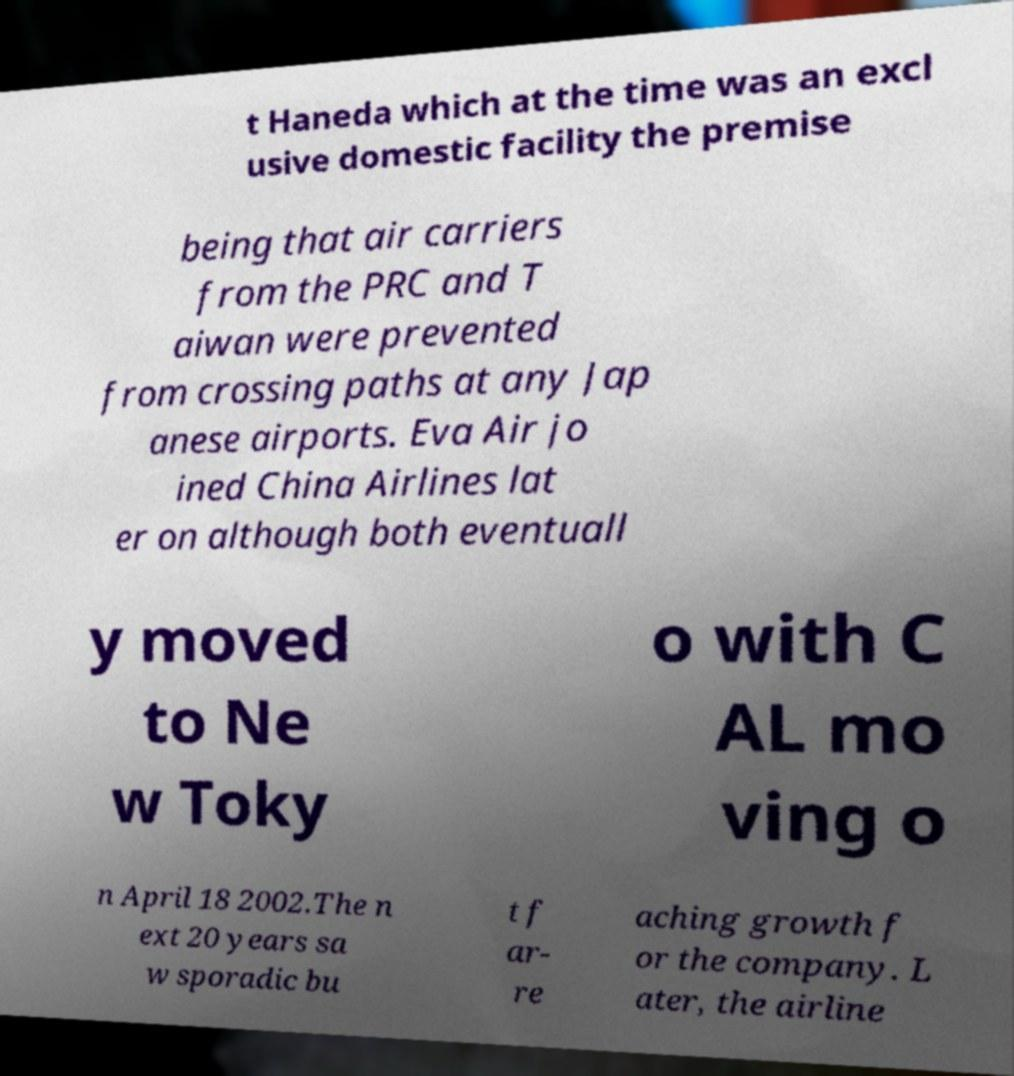For documentation purposes, I need the text within this image transcribed. Could you provide that? t Haneda which at the time was an excl usive domestic facility the premise being that air carriers from the PRC and T aiwan were prevented from crossing paths at any Jap anese airports. Eva Air jo ined China Airlines lat er on although both eventuall y moved to Ne w Toky o with C AL mo ving o n April 18 2002.The n ext 20 years sa w sporadic bu t f ar- re aching growth f or the company. L ater, the airline 